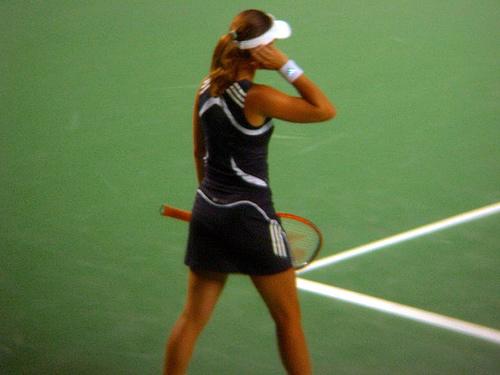Which hand holds the racket?
Quick response, please. Left. What brand of tennis racket does she have?
Quick response, please. Wilson. What is this person wearing on their head?
Be succinct. Visor. What is the color of the tennis racket?
Keep it brief. Orange. What color is the woman's dress?
Short answer required. Black. Is this woman a professional?
Quick response, please. Yes. What color is the ladies top?
Quick response, please. Black. What is she about to hit with the racket?
Quick response, please. Tennis ball. What main two colors are her outfit?
Write a very short answer. Black and white. What color is the racquet?
Write a very short answer. Red. What is this woman wearing on her wrist?
Be succinct. Sweatband. What color is the lady's visor?
Give a very brief answer. White. What color is the court?
Quick response, please. Green. Do you see a shadow?
Concise answer only. No. What is the green thing?
Quick response, please. Court. Did the lady hit the tennis ball?
Quick response, please. No. What is the person holding in their right hand?
Concise answer only. Nothing. Is the woman shrugging?
Answer briefly. No. Is this woman swinging a racket?
Keep it brief. No. What color is her visor?
Quick response, please. White. 